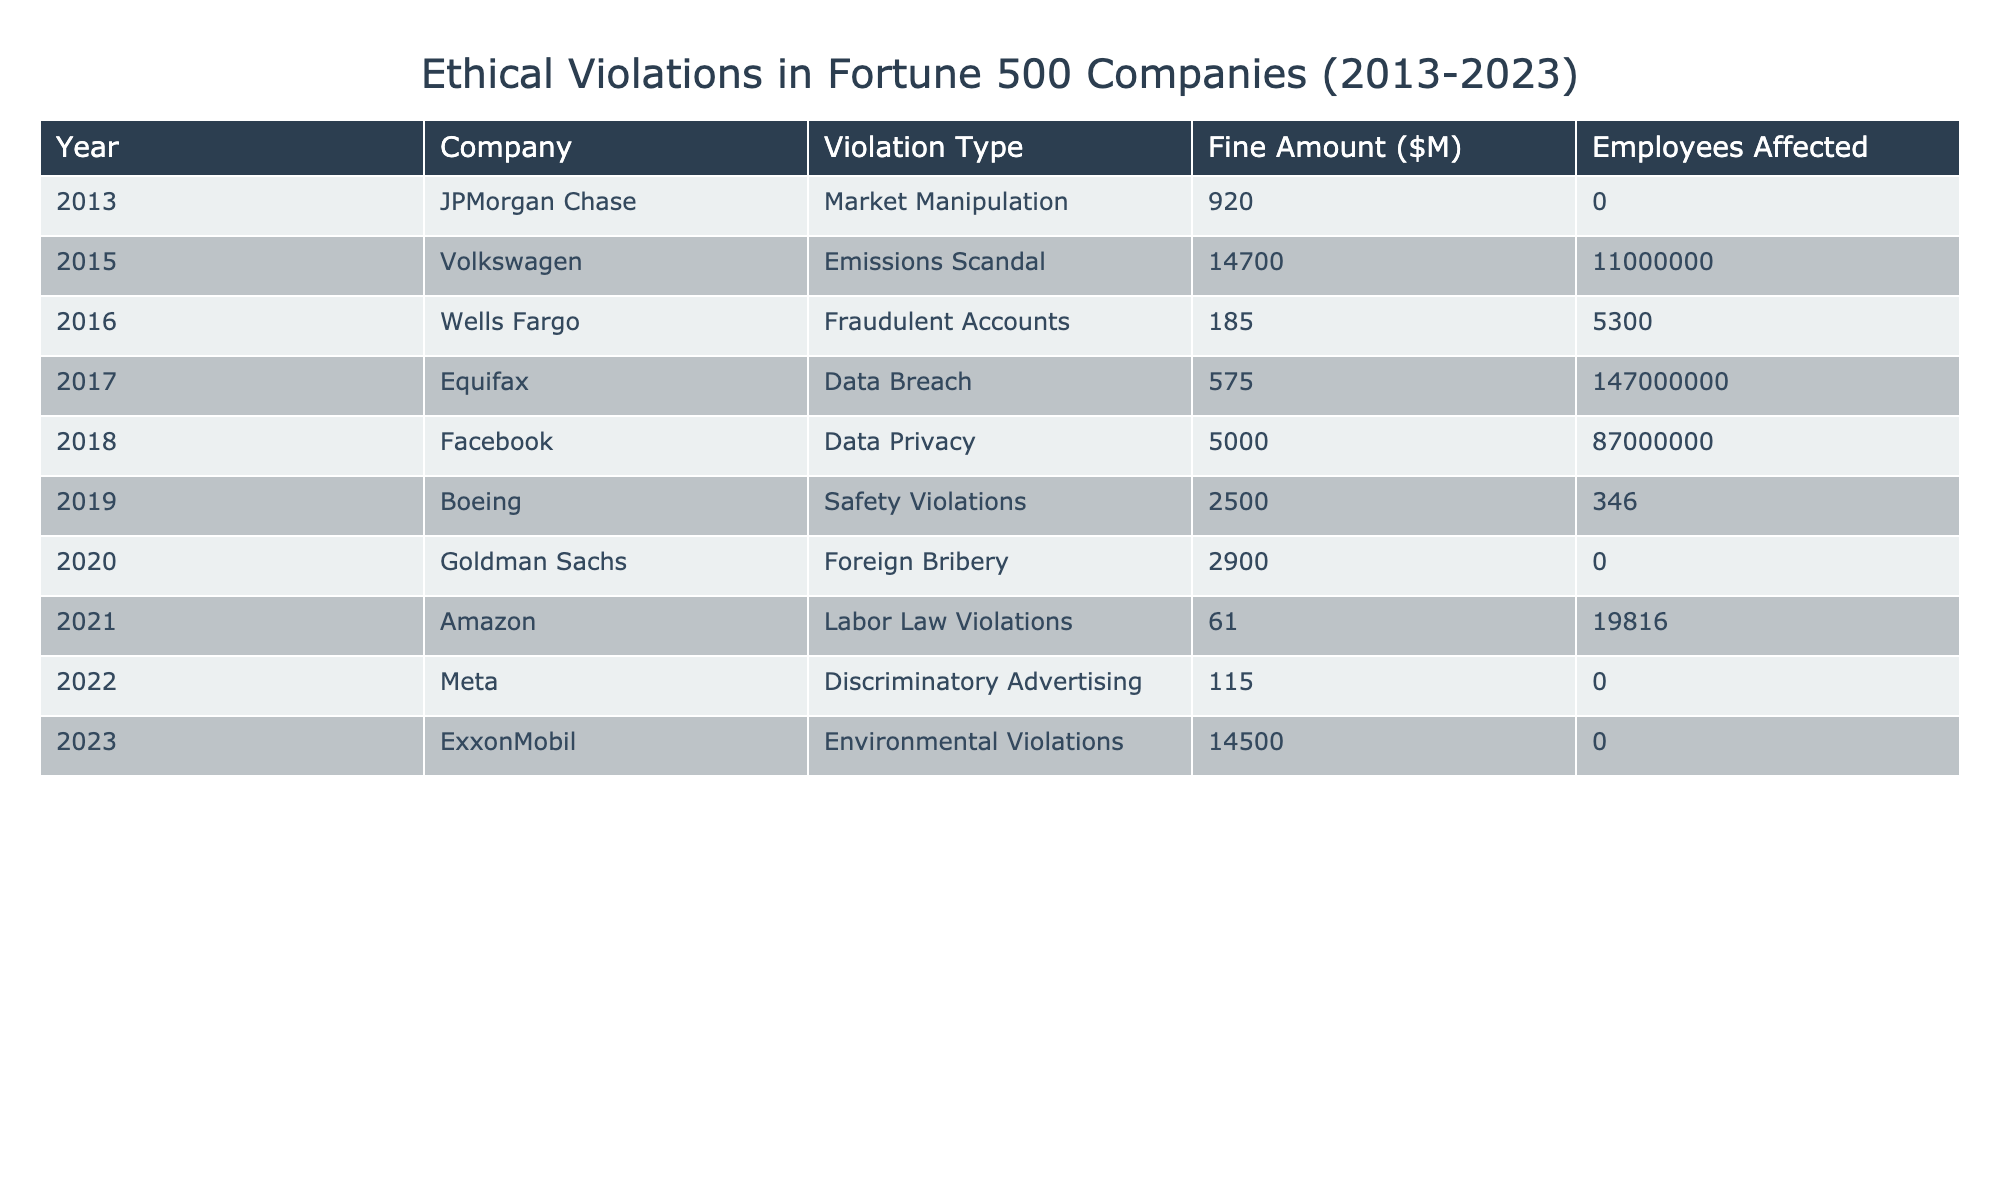What was the highest fine amount recorded in the table? By looking through the 'Fine Amount ($M)' column in the table, the highest recorded fine is 14,700 million dollars for Volkswagen in 2015, representing the emissions scandal.
Answer: 14,700 Which company was fined for fraudulent accounts, and what was the fine amount? The table shows that Wells Fargo was fined 185 million dollars for fraudulent accounts in 2016.
Answer: Wells Fargo, 185 How many employees were affected by the data breach at Equifax? The table indicates that Equifax had 147 million employees affected by its data breach in 2017.
Answer: 147,000,000 What is the total fine amount of all the ethical violations recorded in 2020? The table lists the fine for Goldman Sachs in 2020 as 2,900 million dollars, which is the only entry for that year. Therefore, the total fine amount is 2,900 million dollars.
Answer: 2,900 Between 2013 and 2023, which violation type had the highest number of employees affected? To determine this, we compare the 'Employees Affected' column: Volkswagen's violation affected 11,000,000 employees, which is the highest.
Answer: Emissions Scandal What is the average fine amount across all violations listed in the table? First, sum the fine amounts: 920 + 14,700 + 185 + 575 + 5,000 + 2,500 + 2,900 + 61 + 115 + 14,500 = 40,556 million dollars. Then divide by the number of violations, which is 10: 40,556 / 10 = 4,055.6 million dollars.
Answer: 4,055.6 Is there any instance of ethical violation with no employees affected? By reviewing the 'Employees Affected' column, both JPMorgan Chase and Goldman Sachs record zero employees affected due to their violations.
Answer: Yes Which two companies were involved in environmental violation cases during the recorded period? The table shows that ExxonMobil in 2023 was the only company recorded for environmental violations. There are no other entries.
Answer: ExxonMobil What percentage of the total fines were from the top three fines recorded in the table? The top three fines are VW (14,700), Facebook (5,000), and Boeing (2,500), summing them gives 14,700 + 5,000 + 2,500 = 22,200 million dollars. The total fines sum is 40,556 million dollars. To find the percentage: (22,200 / 40,556) * 100 = 54.7%.
Answer: 54.7% Was there any violation related to labor law issues and how many employees were affected? Upon checking the table, it is clear that Amazon faced labor law violations in 2021 which affected 19,816 employees.
Answer: Yes, 19,816 What was the trend in ethical violation fines from 2013 to 2023 based on the data? By observing the fine amounts year by year, the table indicates a fluctuating trend with a significant spike noted in 2015 due to Volkswagen’s emissions scandal, followed by varying amounts in subsequent years, with increasing fines peaking in 2022.
Answer: Fluctuating with significant increases 